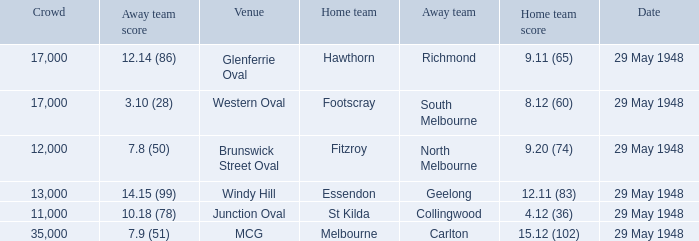During melbourne's home game, who was the away team? Carlton. 